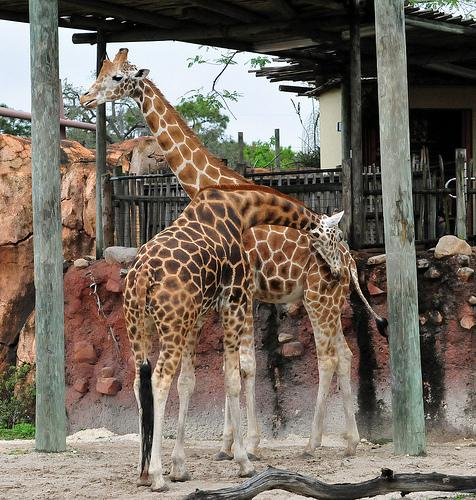Question: why is the giraffe looking down?
Choices:
A. He isn't.
B. Looking at the people.
C. For food.
D. Looking at the baby.
Answer with the letter. Answer: C Question: who is in front of the rock?
Choices:
A. The people.
B. Giraffes.
C. The children.
D. No one.
Answer with the letter. Answer: B Question: how many giraffes are there?
Choices:
A. 1.
B. 2.
C. 3.
D. 4.
Answer with the letter. Answer: B 